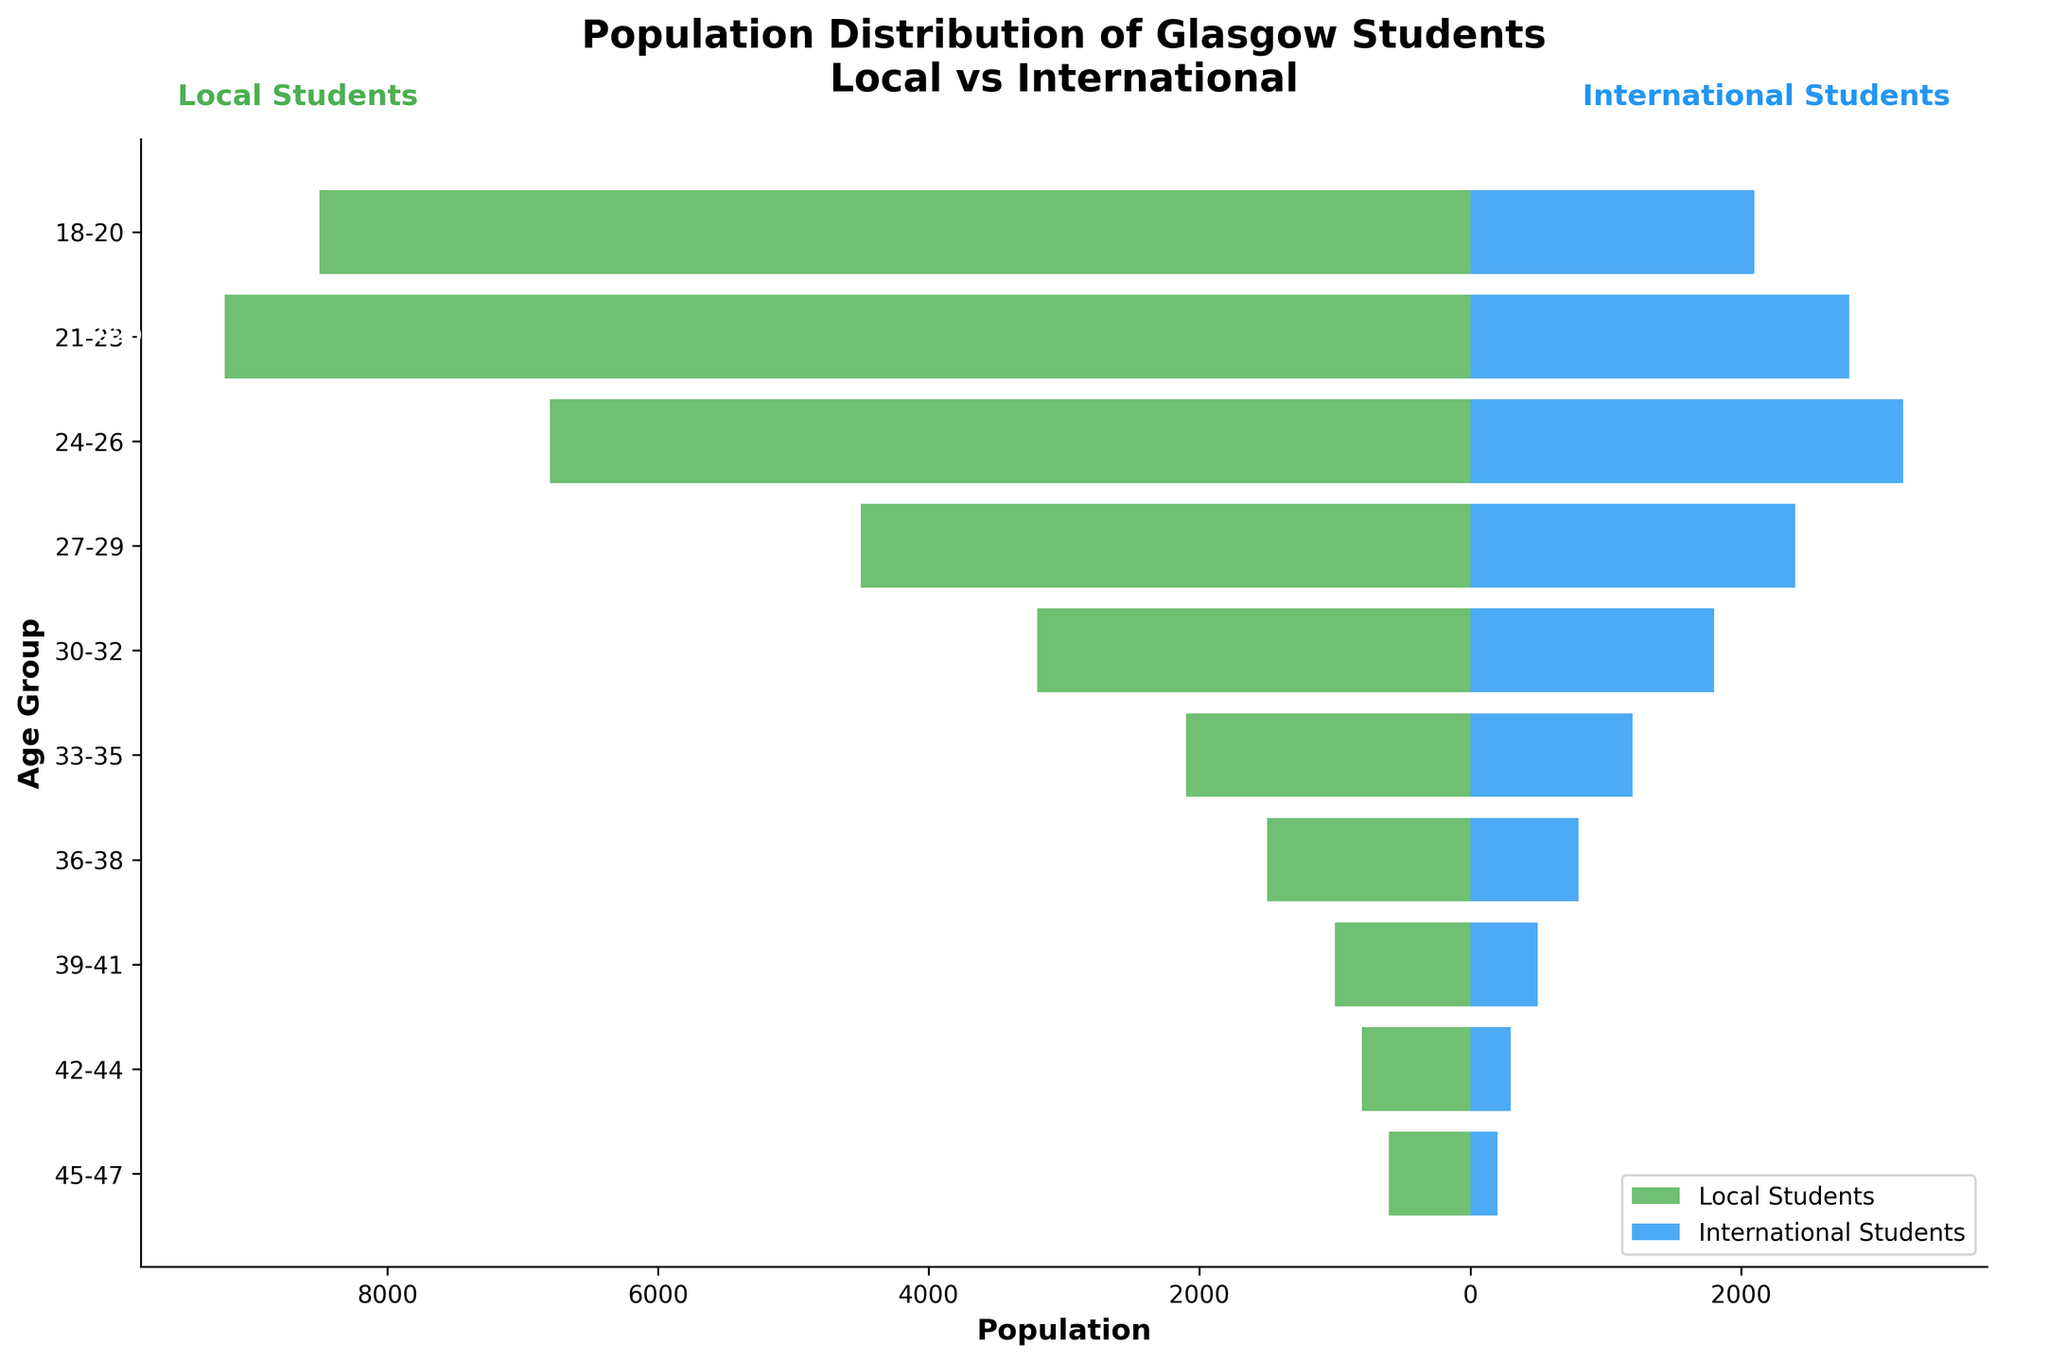Which age group has the highest number of local students? Look at the length of the green bars representing local students. The age group with the longest green bar is 21-23 with 9200 students.
Answer: 21-23 What is the combined number of local and international students in the 24-26 age group? The number of local students in the 24-26 age group is 6800 and the number of international students is 3200. Adding these gives 6800 + 3200 = 10000.
Answer: 10000 How does the number of international students in the 18-20 age group compare to the 21-23 age group? The number of international students in the 18-20 age group is 2100 and in the 21-23 age group is 2800. Comparing these two numbers, 2800 is greater than 2100.
Answer: More in 21-23 What is the ratio of local to international students in the 27-29 age group? The number of local students in the 27-29 age group is 4500 and the number of international students is 2400. The ratio of local to international students is 4500/2400 ≈ 1.875.
Answer: 1.875 Which age group has the smallest difference between local and international student numbers? Calculate the absolute difference for each age group. The group with the smallest difference is the 39-41 age group (1000 - 500 = 500).
Answer: 39-41 Are there more local or international students in the 33-35 age group? For the 33-35 age group, the number of local students is 2100 and the number of international students is 1200. Since 2100 is greater than 1200, there are more local students.
Answer: Local students What percentage of the 30-32 age group are international students? The number of local students in the 30-32 age group is 3200 and the number of international students is 1800. The total number of students is 3200 + 1800 = 5000. The percentage of international students is (1800/5000) * 100 ≈ 36%.
Answer: 36% How many more local students are there than international students in the 21-23 age group? The number of local students in the 21-23 age group is 9200 and the number of international students is 2800. The difference is 9200 - 2800 = 6400.
Answer: 6400 In which age group are the international students the minority? Look at each age group and compare the local and international student numbers. International students are the minority in all age groups.
Answer: All groups What trend do you notice regarding the number of students (both local and international) as the age group increases? As age increases from 18-20 to 45-47, the total number of both local and international students generally decreases. This is evident from the declining lengths of the bars across age groups.
Answer: Decreasing trend 